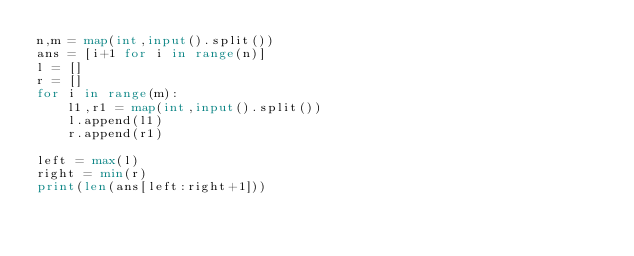Convert code to text. <code><loc_0><loc_0><loc_500><loc_500><_Python_>n,m = map(int,input().split())
ans = [i+1 for i in range(n)]
l = []
r = []
for i in range(m):
    l1,r1 = map(int,input().split())
    l.append(l1)
    r.append(r1)
    
left = max(l)
right = min(r)
print(len(ans[left:right+1]))</code> 